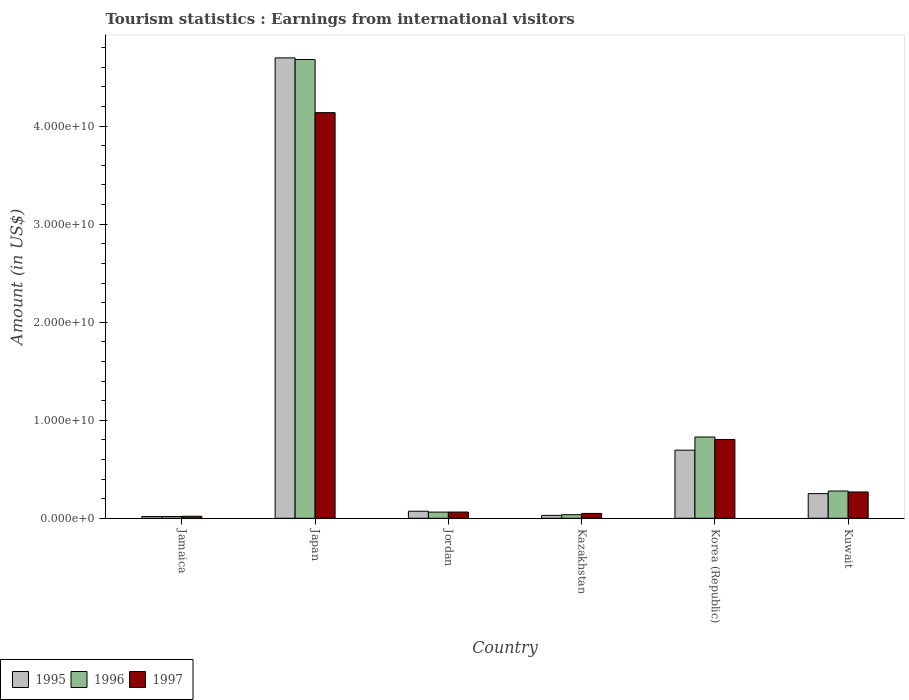How many groups of bars are there?
Your answer should be very brief. 6. Are the number of bars per tick equal to the number of legend labels?
Provide a succinct answer. Yes. Are the number of bars on each tick of the X-axis equal?
Your answer should be very brief. Yes. How many bars are there on the 3rd tick from the left?
Your answer should be compact. 3. How many bars are there on the 4th tick from the right?
Give a very brief answer. 3. What is the label of the 3rd group of bars from the left?
Ensure brevity in your answer.  Jordan. In how many cases, is the number of bars for a given country not equal to the number of legend labels?
Make the answer very short. 0. What is the earnings from international visitors in 1995 in Jamaica?
Your answer should be compact. 1.73e+08. Across all countries, what is the maximum earnings from international visitors in 1996?
Offer a terse response. 4.68e+1. Across all countries, what is the minimum earnings from international visitors in 1996?
Make the answer very short. 1.81e+08. In which country was the earnings from international visitors in 1995 maximum?
Ensure brevity in your answer.  Japan. In which country was the earnings from international visitors in 1996 minimum?
Make the answer very short. Jamaica. What is the total earnings from international visitors in 1997 in the graph?
Give a very brief answer. 5.34e+1. What is the difference between the earnings from international visitors in 1996 in Japan and that in Kazakhstan?
Offer a very short reply. 4.64e+1. What is the difference between the earnings from international visitors in 1997 in Jordan and the earnings from international visitors in 1996 in Japan?
Ensure brevity in your answer.  -4.62e+1. What is the average earnings from international visitors in 1995 per country?
Offer a terse response. 9.60e+09. What is the difference between the earnings from international visitors of/in 1997 and earnings from international visitors of/in 1995 in Jordan?
Ensure brevity in your answer.  -8.40e+07. What is the ratio of the earnings from international visitors in 1996 in Jamaica to that in Kazakhstan?
Your response must be concise. 0.5. Is the earnings from international visitors in 1995 in Jamaica less than that in Korea (Republic)?
Your answer should be very brief. Yes. What is the difference between the highest and the second highest earnings from international visitors in 1995?
Ensure brevity in your answer.  4.45e+1. What is the difference between the highest and the lowest earnings from international visitors in 1995?
Your answer should be compact. 4.68e+1. How many bars are there?
Your response must be concise. 18. What is the difference between two consecutive major ticks on the Y-axis?
Provide a short and direct response. 1.00e+1. Are the values on the major ticks of Y-axis written in scientific E-notation?
Offer a very short reply. Yes. Where does the legend appear in the graph?
Offer a very short reply. Bottom left. How many legend labels are there?
Make the answer very short. 3. How are the legend labels stacked?
Offer a very short reply. Horizontal. What is the title of the graph?
Give a very brief answer. Tourism statistics : Earnings from international visitors. What is the Amount (in US$) in 1995 in Jamaica?
Your answer should be very brief. 1.73e+08. What is the Amount (in US$) of 1996 in Jamaica?
Keep it short and to the point. 1.81e+08. What is the Amount (in US$) of 1997 in Jamaica?
Provide a short and direct response. 2.05e+08. What is the Amount (in US$) in 1995 in Japan?
Your response must be concise. 4.70e+1. What is the Amount (in US$) of 1996 in Japan?
Provide a short and direct response. 4.68e+1. What is the Amount (in US$) in 1997 in Japan?
Offer a terse response. 4.14e+1. What is the Amount (in US$) of 1995 in Jordan?
Your answer should be very brief. 7.19e+08. What is the Amount (in US$) of 1996 in Jordan?
Give a very brief answer. 6.30e+08. What is the Amount (in US$) of 1997 in Jordan?
Provide a short and direct response. 6.35e+08. What is the Amount (in US$) of 1995 in Kazakhstan?
Keep it short and to the point. 2.96e+08. What is the Amount (in US$) in 1996 in Kazakhstan?
Offer a very short reply. 3.64e+08. What is the Amount (in US$) in 1997 in Kazakhstan?
Offer a very short reply. 4.94e+08. What is the Amount (in US$) of 1995 in Korea (Republic)?
Ensure brevity in your answer.  6.95e+09. What is the Amount (in US$) in 1996 in Korea (Republic)?
Keep it short and to the point. 8.29e+09. What is the Amount (in US$) in 1997 in Korea (Republic)?
Give a very brief answer. 8.04e+09. What is the Amount (in US$) in 1995 in Kuwait?
Your answer should be compact. 2.51e+09. What is the Amount (in US$) in 1996 in Kuwait?
Your answer should be very brief. 2.78e+09. What is the Amount (in US$) in 1997 in Kuwait?
Provide a short and direct response. 2.68e+09. Across all countries, what is the maximum Amount (in US$) in 1995?
Your response must be concise. 4.70e+1. Across all countries, what is the maximum Amount (in US$) in 1996?
Your answer should be compact. 4.68e+1. Across all countries, what is the maximum Amount (in US$) of 1997?
Your answer should be compact. 4.14e+1. Across all countries, what is the minimum Amount (in US$) of 1995?
Your answer should be compact. 1.73e+08. Across all countries, what is the minimum Amount (in US$) of 1996?
Your answer should be compact. 1.81e+08. Across all countries, what is the minimum Amount (in US$) in 1997?
Ensure brevity in your answer.  2.05e+08. What is the total Amount (in US$) in 1995 in the graph?
Ensure brevity in your answer.  5.76e+1. What is the total Amount (in US$) of 1996 in the graph?
Give a very brief answer. 5.90e+1. What is the total Amount (in US$) in 1997 in the graph?
Offer a very short reply. 5.34e+1. What is the difference between the Amount (in US$) in 1995 in Jamaica and that in Japan?
Offer a terse response. -4.68e+1. What is the difference between the Amount (in US$) of 1996 in Jamaica and that in Japan?
Ensure brevity in your answer.  -4.66e+1. What is the difference between the Amount (in US$) in 1997 in Jamaica and that in Japan?
Ensure brevity in your answer.  -4.12e+1. What is the difference between the Amount (in US$) of 1995 in Jamaica and that in Jordan?
Provide a succinct answer. -5.46e+08. What is the difference between the Amount (in US$) of 1996 in Jamaica and that in Jordan?
Offer a very short reply. -4.49e+08. What is the difference between the Amount (in US$) of 1997 in Jamaica and that in Jordan?
Provide a short and direct response. -4.30e+08. What is the difference between the Amount (in US$) of 1995 in Jamaica and that in Kazakhstan?
Provide a succinct answer. -1.23e+08. What is the difference between the Amount (in US$) of 1996 in Jamaica and that in Kazakhstan?
Your answer should be compact. -1.83e+08. What is the difference between the Amount (in US$) in 1997 in Jamaica and that in Kazakhstan?
Make the answer very short. -2.89e+08. What is the difference between the Amount (in US$) of 1995 in Jamaica and that in Korea (Republic)?
Your response must be concise. -6.77e+09. What is the difference between the Amount (in US$) of 1996 in Jamaica and that in Korea (Republic)?
Ensure brevity in your answer.  -8.11e+09. What is the difference between the Amount (in US$) in 1997 in Jamaica and that in Korea (Republic)?
Make the answer very short. -7.83e+09. What is the difference between the Amount (in US$) of 1995 in Jamaica and that in Kuwait?
Your answer should be compact. -2.34e+09. What is the difference between the Amount (in US$) in 1996 in Jamaica and that in Kuwait?
Ensure brevity in your answer.  -2.60e+09. What is the difference between the Amount (in US$) in 1997 in Jamaica and that in Kuwait?
Your response must be concise. -2.48e+09. What is the difference between the Amount (in US$) in 1995 in Japan and that in Jordan?
Offer a very short reply. 4.62e+1. What is the difference between the Amount (in US$) in 1996 in Japan and that in Jordan?
Your response must be concise. 4.62e+1. What is the difference between the Amount (in US$) of 1997 in Japan and that in Jordan?
Keep it short and to the point. 4.07e+1. What is the difference between the Amount (in US$) of 1995 in Japan and that in Kazakhstan?
Offer a terse response. 4.67e+1. What is the difference between the Amount (in US$) of 1996 in Japan and that in Kazakhstan?
Offer a terse response. 4.64e+1. What is the difference between the Amount (in US$) in 1997 in Japan and that in Kazakhstan?
Your answer should be compact. 4.09e+1. What is the difference between the Amount (in US$) of 1995 in Japan and that in Korea (Republic)?
Offer a terse response. 4.00e+1. What is the difference between the Amount (in US$) of 1996 in Japan and that in Korea (Republic)?
Offer a terse response. 3.85e+1. What is the difference between the Amount (in US$) of 1997 in Japan and that in Korea (Republic)?
Make the answer very short. 3.33e+1. What is the difference between the Amount (in US$) of 1995 in Japan and that in Kuwait?
Keep it short and to the point. 4.45e+1. What is the difference between the Amount (in US$) in 1996 in Japan and that in Kuwait?
Offer a very short reply. 4.40e+1. What is the difference between the Amount (in US$) of 1997 in Japan and that in Kuwait?
Offer a terse response. 3.87e+1. What is the difference between the Amount (in US$) in 1995 in Jordan and that in Kazakhstan?
Offer a terse response. 4.23e+08. What is the difference between the Amount (in US$) of 1996 in Jordan and that in Kazakhstan?
Provide a short and direct response. 2.66e+08. What is the difference between the Amount (in US$) in 1997 in Jordan and that in Kazakhstan?
Provide a succinct answer. 1.41e+08. What is the difference between the Amount (in US$) of 1995 in Jordan and that in Korea (Republic)?
Make the answer very short. -6.23e+09. What is the difference between the Amount (in US$) of 1996 in Jordan and that in Korea (Republic)?
Provide a succinct answer. -7.66e+09. What is the difference between the Amount (in US$) in 1997 in Jordan and that in Korea (Republic)?
Make the answer very short. -7.40e+09. What is the difference between the Amount (in US$) of 1995 in Jordan and that in Kuwait?
Offer a terse response. -1.80e+09. What is the difference between the Amount (in US$) of 1996 in Jordan and that in Kuwait?
Offer a terse response. -2.15e+09. What is the difference between the Amount (in US$) of 1997 in Jordan and that in Kuwait?
Provide a succinct answer. -2.05e+09. What is the difference between the Amount (in US$) in 1995 in Kazakhstan and that in Korea (Republic)?
Provide a succinct answer. -6.65e+09. What is the difference between the Amount (in US$) in 1996 in Kazakhstan and that in Korea (Republic)?
Make the answer very short. -7.93e+09. What is the difference between the Amount (in US$) of 1997 in Kazakhstan and that in Korea (Republic)?
Your answer should be very brief. -7.54e+09. What is the difference between the Amount (in US$) of 1995 in Kazakhstan and that in Kuwait?
Make the answer very short. -2.22e+09. What is the difference between the Amount (in US$) of 1996 in Kazakhstan and that in Kuwait?
Provide a succinct answer. -2.42e+09. What is the difference between the Amount (in US$) in 1997 in Kazakhstan and that in Kuwait?
Provide a short and direct response. -2.19e+09. What is the difference between the Amount (in US$) in 1995 in Korea (Republic) and that in Kuwait?
Your answer should be very brief. 4.43e+09. What is the difference between the Amount (in US$) in 1996 in Korea (Republic) and that in Kuwait?
Offer a terse response. 5.51e+09. What is the difference between the Amount (in US$) of 1997 in Korea (Republic) and that in Kuwait?
Your answer should be very brief. 5.36e+09. What is the difference between the Amount (in US$) in 1995 in Jamaica and the Amount (in US$) in 1996 in Japan?
Your response must be concise. -4.66e+1. What is the difference between the Amount (in US$) in 1995 in Jamaica and the Amount (in US$) in 1997 in Japan?
Ensure brevity in your answer.  -4.12e+1. What is the difference between the Amount (in US$) in 1996 in Jamaica and the Amount (in US$) in 1997 in Japan?
Your response must be concise. -4.12e+1. What is the difference between the Amount (in US$) in 1995 in Jamaica and the Amount (in US$) in 1996 in Jordan?
Offer a very short reply. -4.57e+08. What is the difference between the Amount (in US$) in 1995 in Jamaica and the Amount (in US$) in 1997 in Jordan?
Provide a short and direct response. -4.62e+08. What is the difference between the Amount (in US$) in 1996 in Jamaica and the Amount (in US$) in 1997 in Jordan?
Ensure brevity in your answer.  -4.54e+08. What is the difference between the Amount (in US$) in 1995 in Jamaica and the Amount (in US$) in 1996 in Kazakhstan?
Provide a short and direct response. -1.91e+08. What is the difference between the Amount (in US$) in 1995 in Jamaica and the Amount (in US$) in 1997 in Kazakhstan?
Make the answer very short. -3.21e+08. What is the difference between the Amount (in US$) of 1996 in Jamaica and the Amount (in US$) of 1997 in Kazakhstan?
Make the answer very short. -3.13e+08. What is the difference between the Amount (in US$) in 1995 in Jamaica and the Amount (in US$) in 1996 in Korea (Republic)?
Keep it short and to the point. -8.12e+09. What is the difference between the Amount (in US$) in 1995 in Jamaica and the Amount (in US$) in 1997 in Korea (Republic)?
Offer a terse response. -7.87e+09. What is the difference between the Amount (in US$) of 1996 in Jamaica and the Amount (in US$) of 1997 in Korea (Republic)?
Ensure brevity in your answer.  -7.86e+09. What is the difference between the Amount (in US$) in 1995 in Jamaica and the Amount (in US$) in 1996 in Kuwait?
Offer a very short reply. -2.61e+09. What is the difference between the Amount (in US$) of 1995 in Jamaica and the Amount (in US$) of 1997 in Kuwait?
Offer a terse response. -2.51e+09. What is the difference between the Amount (in US$) in 1996 in Jamaica and the Amount (in US$) in 1997 in Kuwait?
Your answer should be compact. -2.50e+09. What is the difference between the Amount (in US$) of 1995 in Japan and the Amount (in US$) of 1996 in Jordan?
Offer a terse response. 4.63e+1. What is the difference between the Amount (in US$) in 1995 in Japan and the Amount (in US$) in 1997 in Jordan?
Keep it short and to the point. 4.63e+1. What is the difference between the Amount (in US$) of 1996 in Japan and the Amount (in US$) of 1997 in Jordan?
Your response must be concise. 4.62e+1. What is the difference between the Amount (in US$) of 1995 in Japan and the Amount (in US$) of 1996 in Kazakhstan?
Your answer should be compact. 4.66e+1. What is the difference between the Amount (in US$) in 1995 in Japan and the Amount (in US$) in 1997 in Kazakhstan?
Ensure brevity in your answer.  4.65e+1. What is the difference between the Amount (in US$) of 1996 in Japan and the Amount (in US$) of 1997 in Kazakhstan?
Offer a terse response. 4.63e+1. What is the difference between the Amount (in US$) in 1995 in Japan and the Amount (in US$) in 1996 in Korea (Republic)?
Offer a very short reply. 3.87e+1. What is the difference between the Amount (in US$) of 1995 in Japan and the Amount (in US$) of 1997 in Korea (Republic)?
Your answer should be very brief. 3.89e+1. What is the difference between the Amount (in US$) of 1996 in Japan and the Amount (in US$) of 1997 in Korea (Republic)?
Provide a succinct answer. 3.88e+1. What is the difference between the Amount (in US$) of 1995 in Japan and the Amount (in US$) of 1996 in Kuwait?
Offer a very short reply. 4.42e+1. What is the difference between the Amount (in US$) in 1995 in Japan and the Amount (in US$) in 1997 in Kuwait?
Offer a terse response. 4.43e+1. What is the difference between the Amount (in US$) in 1996 in Japan and the Amount (in US$) in 1997 in Kuwait?
Give a very brief answer. 4.41e+1. What is the difference between the Amount (in US$) of 1995 in Jordan and the Amount (in US$) of 1996 in Kazakhstan?
Provide a succinct answer. 3.55e+08. What is the difference between the Amount (in US$) in 1995 in Jordan and the Amount (in US$) in 1997 in Kazakhstan?
Give a very brief answer. 2.25e+08. What is the difference between the Amount (in US$) in 1996 in Jordan and the Amount (in US$) in 1997 in Kazakhstan?
Your answer should be compact. 1.36e+08. What is the difference between the Amount (in US$) in 1995 in Jordan and the Amount (in US$) in 1996 in Korea (Republic)?
Make the answer very short. -7.57e+09. What is the difference between the Amount (in US$) in 1995 in Jordan and the Amount (in US$) in 1997 in Korea (Republic)?
Your answer should be compact. -7.32e+09. What is the difference between the Amount (in US$) of 1996 in Jordan and the Amount (in US$) of 1997 in Korea (Republic)?
Your answer should be compact. -7.41e+09. What is the difference between the Amount (in US$) of 1995 in Jordan and the Amount (in US$) of 1996 in Kuwait?
Ensure brevity in your answer.  -2.06e+09. What is the difference between the Amount (in US$) of 1995 in Jordan and the Amount (in US$) of 1997 in Kuwait?
Your answer should be very brief. -1.96e+09. What is the difference between the Amount (in US$) of 1996 in Jordan and the Amount (in US$) of 1997 in Kuwait?
Your response must be concise. -2.05e+09. What is the difference between the Amount (in US$) in 1995 in Kazakhstan and the Amount (in US$) in 1996 in Korea (Republic)?
Give a very brief answer. -8.00e+09. What is the difference between the Amount (in US$) in 1995 in Kazakhstan and the Amount (in US$) in 1997 in Korea (Republic)?
Make the answer very short. -7.74e+09. What is the difference between the Amount (in US$) in 1996 in Kazakhstan and the Amount (in US$) in 1997 in Korea (Republic)?
Offer a very short reply. -7.68e+09. What is the difference between the Amount (in US$) of 1995 in Kazakhstan and the Amount (in US$) of 1996 in Kuwait?
Your response must be concise. -2.48e+09. What is the difference between the Amount (in US$) in 1995 in Kazakhstan and the Amount (in US$) in 1997 in Kuwait?
Offer a terse response. -2.39e+09. What is the difference between the Amount (in US$) of 1996 in Kazakhstan and the Amount (in US$) of 1997 in Kuwait?
Your response must be concise. -2.32e+09. What is the difference between the Amount (in US$) of 1995 in Korea (Republic) and the Amount (in US$) of 1996 in Kuwait?
Your answer should be very brief. 4.17e+09. What is the difference between the Amount (in US$) of 1995 in Korea (Republic) and the Amount (in US$) of 1997 in Kuwait?
Keep it short and to the point. 4.26e+09. What is the difference between the Amount (in US$) of 1996 in Korea (Republic) and the Amount (in US$) of 1997 in Kuwait?
Give a very brief answer. 5.61e+09. What is the average Amount (in US$) in 1995 per country?
Keep it short and to the point. 9.60e+09. What is the average Amount (in US$) of 1996 per country?
Offer a very short reply. 9.84e+09. What is the average Amount (in US$) of 1997 per country?
Your answer should be compact. 8.91e+09. What is the difference between the Amount (in US$) in 1995 and Amount (in US$) in 1996 in Jamaica?
Give a very brief answer. -8.00e+06. What is the difference between the Amount (in US$) in 1995 and Amount (in US$) in 1997 in Jamaica?
Make the answer very short. -3.20e+07. What is the difference between the Amount (in US$) of 1996 and Amount (in US$) of 1997 in Jamaica?
Offer a terse response. -2.40e+07. What is the difference between the Amount (in US$) in 1995 and Amount (in US$) in 1996 in Japan?
Your response must be concise. 1.66e+08. What is the difference between the Amount (in US$) in 1995 and Amount (in US$) in 1997 in Japan?
Keep it short and to the point. 5.58e+09. What is the difference between the Amount (in US$) of 1996 and Amount (in US$) of 1997 in Japan?
Give a very brief answer. 5.42e+09. What is the difference between the Amount (in US$) in 1995 and Amount (in US$) in 1996 in Jordan?
Offer a very short reply. 8.90e+07. What is the difference between the Amount (in US$) in 1995 and Amount (in US$) in 1997 in Jordan?
Your answer should be compact. 8.40e+07. What is the difference between the Amount (in US$) in 1996 and Amount (in US$) in 1997 in Jordan?
Your answer should be very brief. -5.00e+06. What is the difference between the Amount (in US$) in 1995 and Amount (in US$) in 1996 in Kazakhstan?
Provide a short and direct response. -6.80e+07. What is the difference between the Amount (in US$) of 1995 and Amount (in US$) of 1997 in Kazakhstan?
Provide a short and direct response. -1.98e+08. What is the difference between the Amount (in US$) of 1996 and Amount (in US$) of 1997 in Kazakhstan?
Offer a terse response. -1.30e+08. What is the difference between the Amount (in US$) of 1995 and Amount (in US$) of 1996 in Korea (Republic)?
Keep it short and to the point. -1.34e+09. What is the difference between the Amount (in US$) in 1995 and Amount (in US$) in 1997 in Korea (Republic)?
Offer a terse response. -1.09e+09. What is the difference between the Amount (in US$) in 1996 and Amount (in US$) in 1997 in Korea (Republic)?
Make the answer very short. 2.52e+08. What is the difference between the Amount (in US$) of 1995 and Amount (in US$) of 1996 in Kuwait?
Provide a short and direct response. -2.65e+08. What is the difference between the Amount (in US$) of 1995 and Amount (in US$) of 1997 in Kuwait?
Offer a very short reply. -1.70e+08. What is the difference between the Amount (in US$) of 1996 and Amount (in US$) of 1997 in Kuwait?
Your answer should be compact. 9.50e+07. What is the ratio of the Amount (in US$) in 1995 in Jamaica to that in Japan?
Provide a short and direct response. 0. What is the ratio of the Amount (in US$) in 1996 in Jamaica to that in Japan?
Ensure brevity in your answer.  0. What is the ratio of the Amount (in US$) in 1997 in Jamaica to that in Japan?
Provide a short and direct response. 0.01. What is the ratio of the Amount (in US$) of 1995 in Jamaica to that in Jordan?
Your answer should be compact. 0.24. What is the ratio of the Amount (in US$) of 1996 in Jamaica to that in Jordan?
Provide a short and direct response. 0.29. What is the ratio of the Amount (in US$) of 1997 in Jamaica to that in Jordan?
Offer a terse response. 0.32. What is the ratio of the Amount (in US$) of 1995 in Jamaica to that in Kazakhstan?
Offer a very short reply. 0.58. What is the ratio of the Amount (in US$) of 1996 in Jamaica to that in Kazakhstan?
Make the answer very short. 0.5. What is the ratio of the Amount (in US$) of 1997 in Jamaica to that in Kazakhstan?
Your answer should be very brief. 0.41. What is the ratio of the Amount (in US$) of 1995 in Jamaica to that in Korea (Republic)?
Provide a succinct answer. 0.02. What is the ratio of the Amount (in US$) of 1996 in Jamaica to that in Korea (Republic)?
Provide a short and direct response. 0.02. What is the ratio of the Amount (in US$) in 1997 in Jamaica to that in Korea (Republic)?
Offer a terse response. 0.03. What is the ratio of the Amount (in US$) of 1995 in Jamaica to that in Kuwait?
Your response must be concise. 0.07. What is the ratio of the Amount (in US$) of 1996 in Jamaica to that in Kuwait?
Your response must be concise. 0.07. What is the ratio of the Amount (in US$) of 1997 in Jamaica to that in Kuwait?
Your answer should be compact. 0.08. What is the ratio of the Amount (in US$) of 1995 in Japan to that in Jordan?
Make the answer very short. 65.32. What is the ratio of the Amount (in US$) of 1996 in Japan to that in Jordan?
Offer a terse response. 74.29. What is the ratio of the Amount (in US$) of 1997 in Japan to that in Jordan?
Make the answer very short. 65.17. What is the ratio of the Amount (in US$) in 1995 in Japan to that in Kazakhstan?
Ensure brevity in your answer.  158.67. What is the ratio of the Amount (in US$) in 1996 in Japan to that in Kazakhstan?
Provide a short and direct response. 128.57. What is the ratio of the Amount (in US$) in 1997 in Japan to that in Kazakhstan?
Offer a terse response. 83.77. What is the ratio of the Amount (in US$) of 1995 in Japan to that in Korea (Republic)?
Provide a short and direct response. 6.76. What is the ratio of the Amount (in US$) of 1996 in Japan to that in Korea (Republic)?
Make the answer very short. 5.64. What is the ratio of the Amount (in US$) of 1997 in Japan to that in Korea (Republic)?
Your response must be concise. 5.15. What is the ratio of the Amount (in US$) of 1995 in Japan to that in Kuwait?
Give a very brief answer. 18.68. What is the ratio of the Amount (in US$) of 1996 in Japan to that in Kuwait?
Your answer should be compact. 16.84. What is the ratio of the Amount (in US$) in 1997 in Japan to that in Kuwait?
Offer a very short reply. 15.42. What is the ratio of the Amount (in US$) of 1995 in Jordan to that in Kazakhstan?
Your response must be concise. 2.43. What is the ratio of the Amount (in US$) in 1996 in Jordan to that in Kazakhstan?
Keep it short and to the point. 1.73. What is the ratio of the Amount (in US$) in 1997 in Jordan to that in Kazakhstan?
Your answer should be very brief. 1.29. What is the ratio of the Amount (in US$) in 1995 in Jordan to that in Korea (Republic)?
Ensure brevity in your answer.  0.1. What is the ratio of the Amount (in US$) of 1996 in Jordan to that in Korea (Republic)?
Your answer should be very brief. 0.08. What is the ratio of the Amount (in US$) of 1997 in Jordan to that in Korea (Republic)?
Make the answer very short. 0.08. What is the ratio of the Amount (in US$) of 1995 in Jordan to that in Kuwait?
Make the answer very short. 0.29. What is the ratio of the Amount (in US$) in 1996 in Jordan to that in Kuwait?
Your answer should be very brief. 0.23. What is the ratio of the Amount (in US$) of 1997 in Jordan to that in Kuwait?
Provide a succinct answer. 0.24. What is the ratio of the Amount (in US$) in 1995 in Kazakhstan to that in Korea (Republic)?
Provide a succinct answer. 0.04. What is the ratio of the Amount (in US$) in 1996 in Kazakhstan to that in Korea (Republic)?
Your answer should be compact. 0.04. What is the ratio of the Amount (in US$) in 1997 in Kazakhstan to that in Korea (Republic)?
Keep it short and to the point. 0.06. What is the ratio of the Amount (in US$) of 1995 in Kazakhstan to that in Kuwait?
Keep it short and to the point. 0.12. What is the ratio of the Amount (in US$) in 1996 in Kazakhstan to that in Kuwait?
Your answer should be compact. 0.13. What is the ratio of the Amount (in US$) in 1997 in Kazakhstan to that in Kuwait?
Make the answer very short. 0.18. What is the ratio of the Amount (in US$) in 1995 in Korea (Republic) to that in Kuwait?
Offer a very short reply. 2.76. What is the ratio of the Amount (in US$) in 1996 in Korea (Republic) to that in Kuwait?
Offer a very short reply. 2.98. What is the ratio of the Amount (in US$) of 1997 in Korea (Republic) to that in Kuwait?
Your answer should be compact. 3. What is the difference between the highest and the second highest Amount (in US$) of 1995?
Provide a short and direct response. 4.00e+1. What is the difference between the highest and the second highest Amount (in US$) of 1996?
Give a very brief answer. 3.85e+1. What is the difference between the highest and the second highest Amount (in US$) of 1997?
Give a very brief answer. 3.33e+1. What is the difference between the highest and the lowest Amount (in US$) of 1995?
Provide a short and direct response. 4.68e+1. What is the difference between the highest and the lowest Amount (in US$) in 1996?
Offer a very short reply. 4.66e+1. What is the difference between the highest and the lowest Amount (in US$) of 1997?
Offer a very short reply. 4.12e+1. 